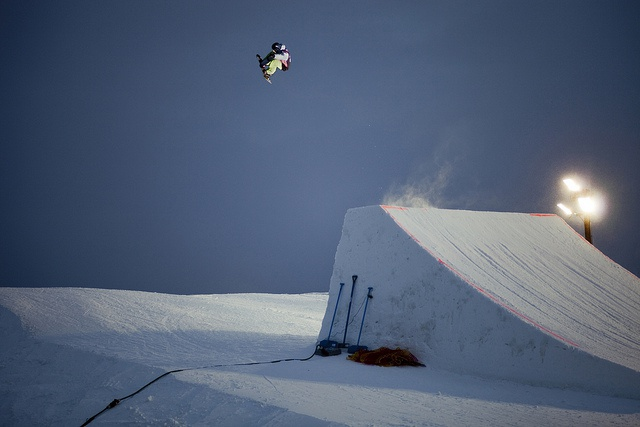Describe the objects in this image and their specific colors. I can see people in black, lightgray, beige, and gray tones and snowboard in black, gray, and darkgray tones in this image. 